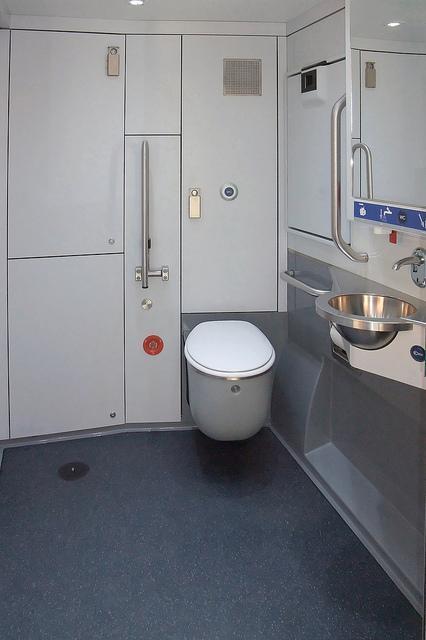How many red fish kites are there?
Give a very brief answer. 0. 